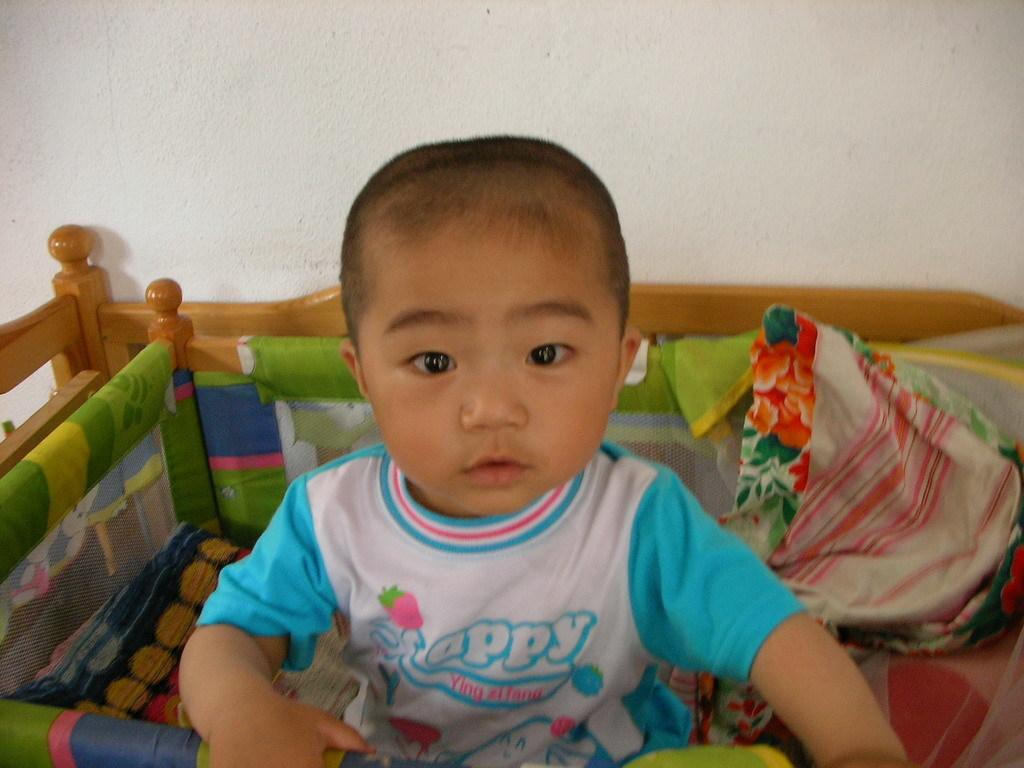Who is present in the image? There is a child in the image. What can be seen near the child? There are clothes and objects in the image. What is visible in the background of the image? There is a wall in the background of the image. Where is the drain located in the image? There is no drain present in the image. What type of paper is being used by the child in the image? There is no paper visible in the image. 